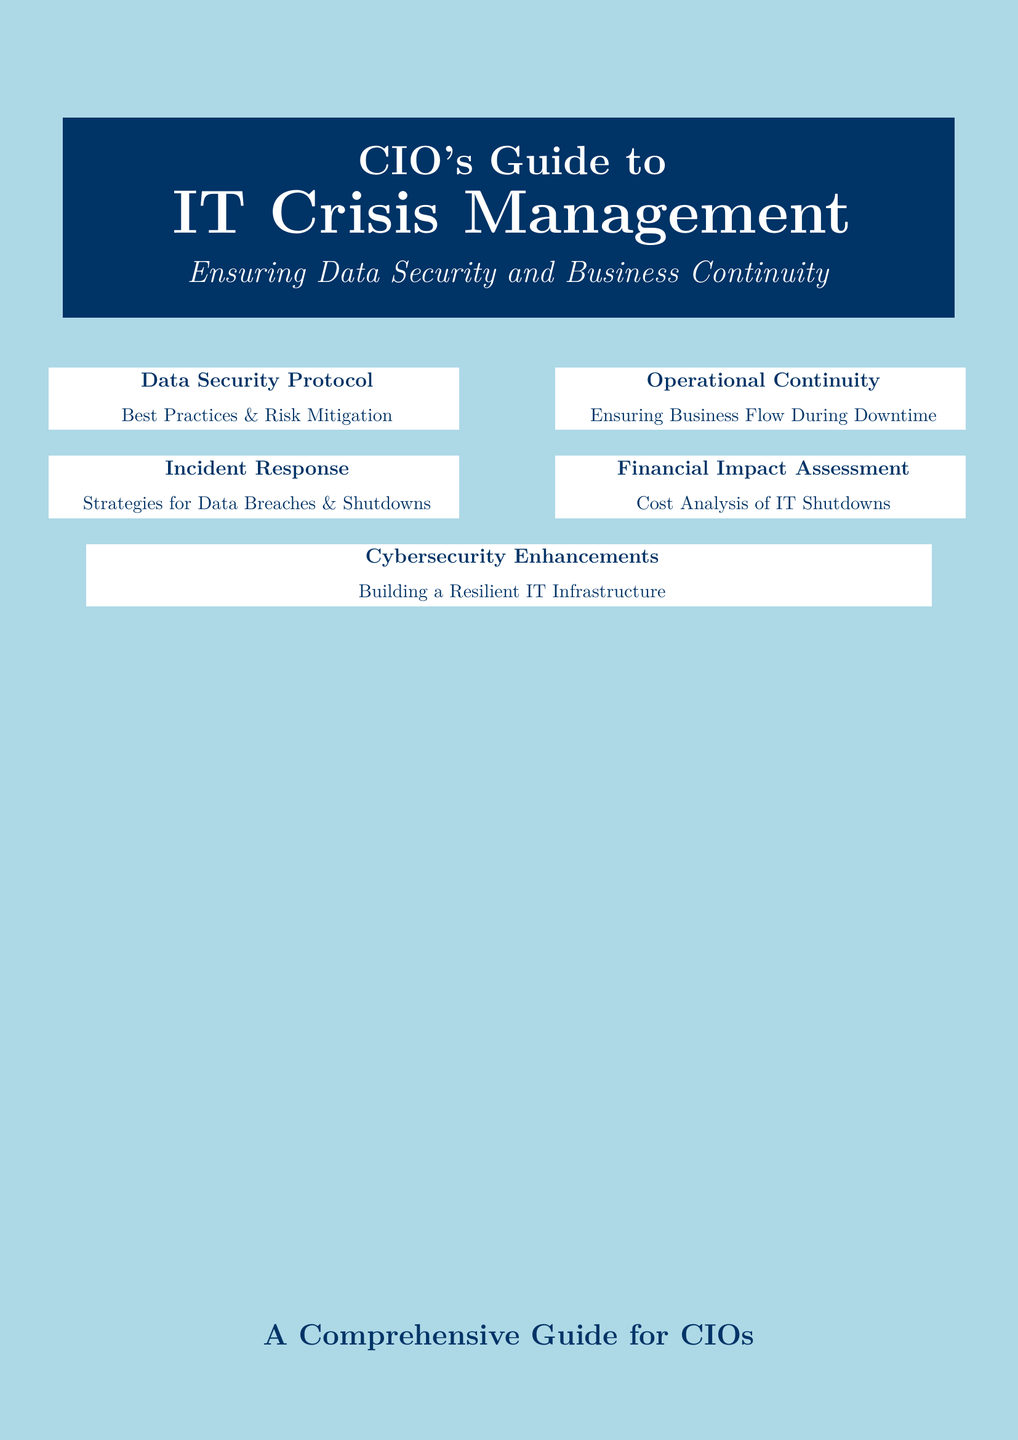What is the title of the guide? The title of the guide is prominently displayed at the top of the document, which is "CIO's Guide to IT Crisis Management."
Answer: CIO's Guide to IT Crisis Management How many main topics are covered in the document? The document covers five main topics as indicated by the sections listed on the cover.
Answer: Five What is the main focus of the section on data security? The section on data security focuses on best practices and risk mitigation, detailing approaches to protect data during a crisis.
Answer: Best Practices & Risk Mitigation What visual theme signifies security in the first section? The visual theme includes a closed vault and digital padlock which symbolize security measures for data.
Answer: Closed vault and digital padlock What type of analysis is highlighted in the financial impact section? The financial impact section emphasizes cost analysis associated with IT shutdowns, important for understanding operational risks.
Answer: Cost Analysis Which section deals with response strategies? The incident response strategies are specifically addressed in the section labeled "Incident Response."
Answer: Incident Response How is continuity emphasized in the operational section? Continuity is emphasized through the slogan "Ensuring Business Flow During Downtime," indicating its importance during operational disruptions.
Answer: Ensuring Business Flow During Downtime What overarching message does the cover convey for CIOs? The cover conveys a message of comprehensive guidance essential for CIOs to manage crises effectively, ensuring security and continuity.
Answer: A Comprehensive Guide for CIOs 